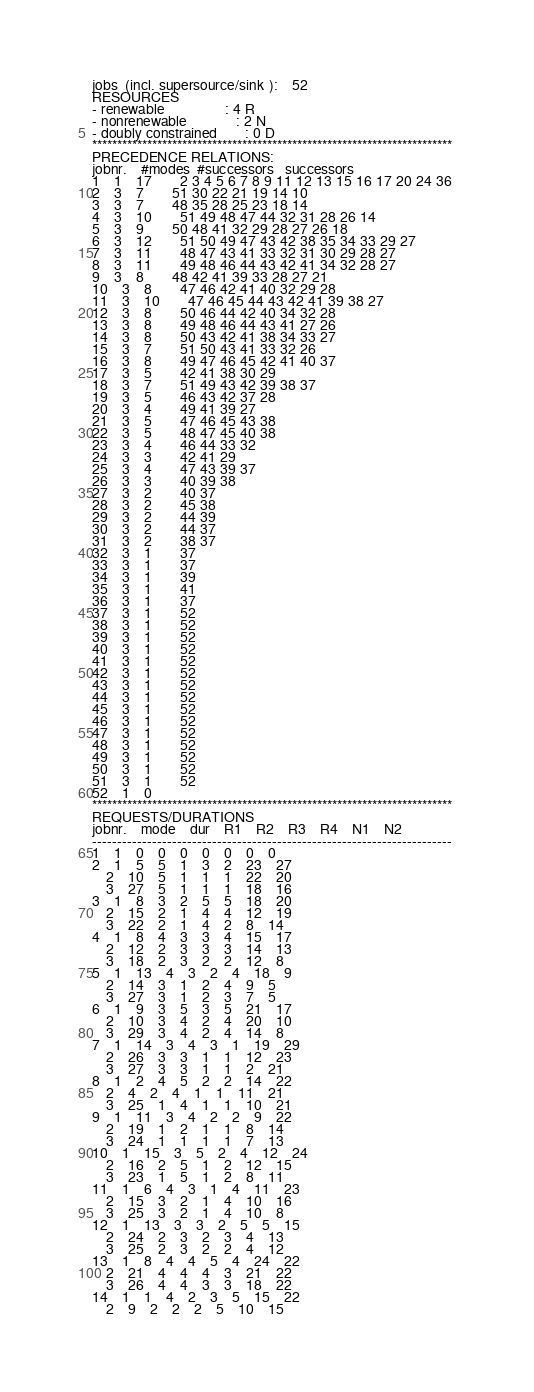<code> <loc_0><loc_0><loc_500><loc_500><_ObjectiveC_>jobs  (incl. supersource/sink ):	52
RESOURCES
- renewable                 : 4 R
- nonrenewable              : 2 N
- doubly constrained        : 0 D
************************************************************************
PRECEDENCE RELATIONS:
jobnr.    #modes  #successors   successors
1	1	17		2 3 4 5 6 7 8 9 11 12 13 15 16 17 20 24 36 
2	3	7		51 30 22 21 19 14 10 
3	3	7		48 35 28 25 23 18 14 
4	3	10		51 49 48 47 44 32 31 28 26 14 
5	3	9		50 48 41 32 29 28 27 26 18 
6	3	12		51 50 49 47 43 42 38 35 34 33 29 27 
7	3	11		48 47 43 41 33 32 31 30 29 28 27 
8	3	11		49 48 46 44 43 42 41 34 32 28 27 
9	3	8		48 42 41 39 33 28 27 21 
10	3	8		47 46 42 41 40 32 29 28 
11	3	10		47 46 45 44 43 42 41 39 38 27 
12	3	8		50 46 44 42 40 34 32 28 
13	3	8		49 48 46 44 43 41 27 26 
14	3	8		50 43 42 41 38 34 33 27 
15	3	7		51 50 43 41 33 32 26 
16	3	8		49 47 46 45 42 41 40 37 
17	3	5		42 41 38 30 29 
18	3	7		51 49 43 42 39 38 37 
19	3	5		46 43 42 37 28 
20	3	4		49 41 39 27 
21	3	5		47 46 45 43 38 
22	3	5		48 47 45 40 38 
23	3	4		46 44 33 32 
24	3	3		42 41 29 
25	3	4		47 43 39 37 
26	3	3		40 39 38 
27	3	2		40 37 
28	3	2		45 38 
29	3	2		44 39 
30	3	2		44 37 
31	3	2		38 37 
32	3	1		37 
33	3	1		37 
34	3	1		39 
35	3	1		41 
36	3	1		37 
37	3	1		52 
38	3	1		52 
39	3	1		52 
40	3	1		52 
41	3	1		52 
42	3	1		52 
43	3	1		52 
44	3	1		52 
45	3	1		52 
46	3	1		52 
47	3	1		52 
48	3	1		52 
49	3	1		52 
50	3	1		52 
51	3	1		52 
52	1	0		
************************************************************************
REQUESTS/DURATIONS
jobnr.	mode	dur	R1	R2	R3	R4	N1	N2	
------------------------------------------------------------------------
1	1	0	0	0	0	0	0	0	
2	1	5	5	1	3	2	23	27	
	2	10	5	1	1	1	22	20	
	3	27	5	1	1	1	18	16	
3	1	8	3	2	5	5	18	20	
	2	15	2	1	4	4	12	19	
	3	22	2	1	4	2	8	14	
4	1	8	4	3	3	4	15	17	
	2	12	2	3	3	3	14	13	
	3	18	2	3	2	2	12	8	
5	1	13	4	3	2	4	18	9	
	2	14	3	1	2	4	9	5	
	3	27	3	1	2	3	7	5	
6	1	9	3	5	3	5	21	17	
	2	10	3	4	2	4	20	10	
	3	29	3	4	2	4	14	8	
7	1	14	3	4	3	1	19	29	
	2	26	3	3	1	1	12	23	
	3	27	3	3	1	1	2	21	
8	1	2	4	5	2	2	14	22	
	2	4	2	4	1	1	11	21	
	3	25	1	4	1	1	10	21	
9	1	11	3	4	2	2	9	22	
	2	19	1	2	1	1	8	14	
	3	24	1	1	1	1	7	13	
10	1	15	3	5	2	4	12	24	
	2	16	2	5	1	2	12	15	
	3	23	1	5	1	2	8	11	
11	1	6	4	3	1	4	11	23	
	2	15	3	2	1	4	10	16	
	3	25	3	2	1	4	10	8	
12	1	13	3	3	2	5	5	15	
	2	24	2	3	2	3	4	13	
	3	25	2	3	2	2	4	12	
13	1	8	4	4	5	4	24	22	
	2	21	4	4	4	3	21	22	
	3	26	4	4	3	3	18	22	
14	1	1	4	2	3	5	15	22	
	2	9	2	2	2	5	10	15	</code> 